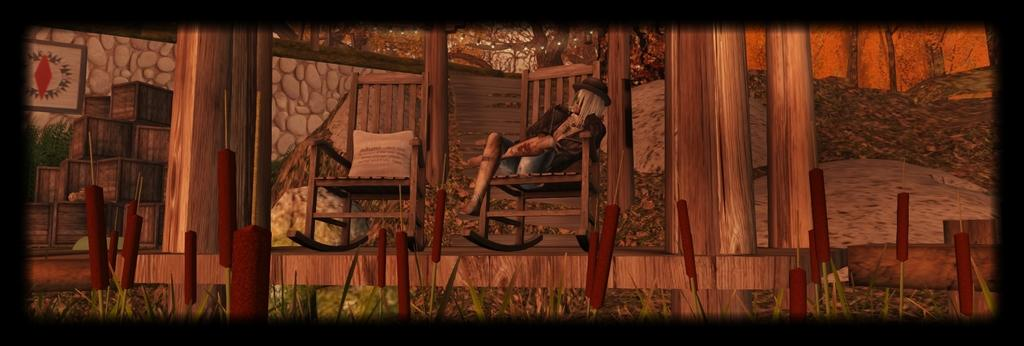What type of artwork is depicted in the image? The image appears to be a painting. How many chairs are visible in the painting? There are 2 chairs in the painting. What is the man in the painting doing? A man is sitting on one of the chairs. What other objects can be seen in the painting? There are wooden boxes and pillars in the painting. How far away is the brain from the poison in the painting? There is no brain or poison present in the painting; it features chairs, a man, wooden boxes, and pillars. 